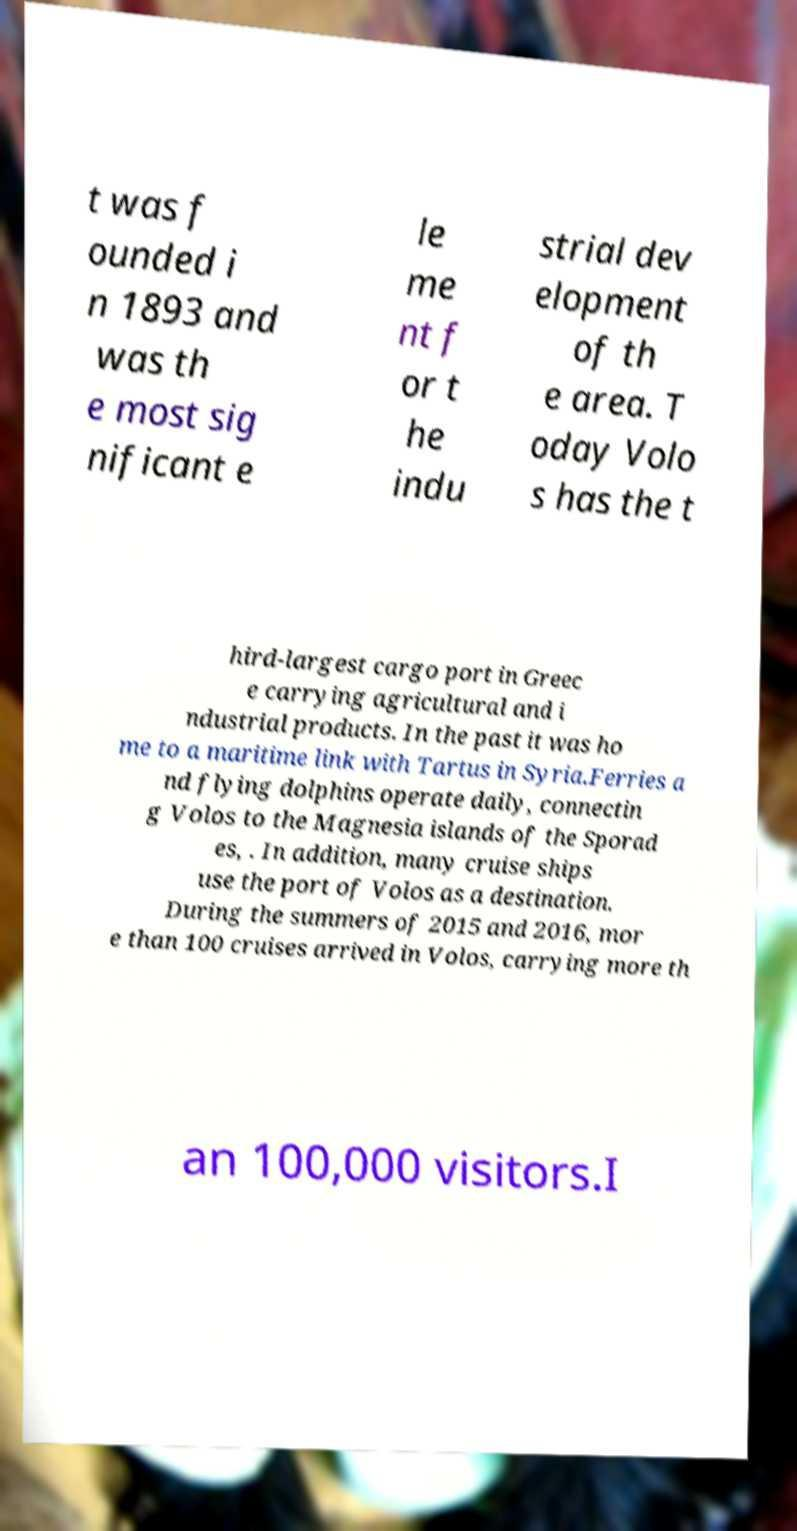What messages or text are displayed in this image? I need them in a readable, typed format. t was f ounded i n 1893 and was th e most sig nificant e le me nt f or t he indu strial dev elopment of th e area. T oday Volo s has the t hird-largest cargo port in Greec e carrying agricultural and i ndustrial products. In the past it was ho me to a maritime link with Tartus in Syria.Ferries a nd flying dolphins operate daily, connectin g Volos to the Magnesia islands of the Sporad es, . In addition, many cruise ships use the port of Volos as a destination. During the summers of 2015 and 2016, mor e than 100 cruises arrived in Volos, carrying more th an 100,000 visitors.I 